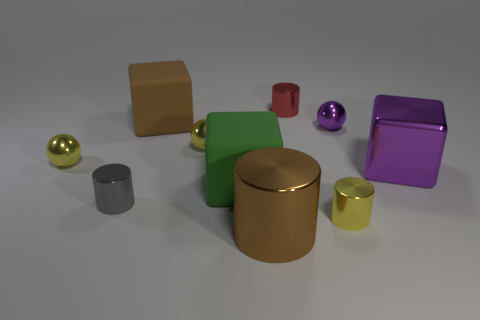What can be inferred about the light source in this scene? Based on the soft shadows and the diffused reflections, we can infer that the light source in this scene is diffused, possibly indicating overhead lighting with some ambiance. Is there more than one light source? It's not entirely clear if there's a single light source or multiple; however, considering the uniformity of the shadows, it is likely that there is one main light source, possibly supplemented by ambient light. 